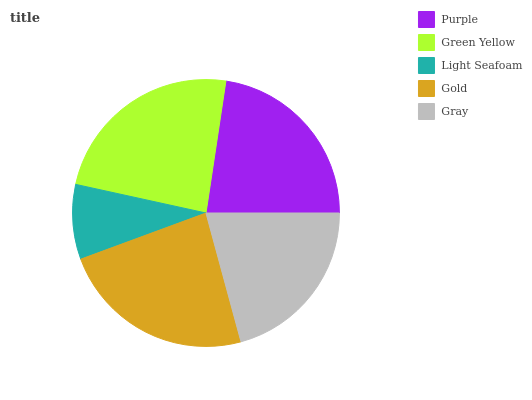Is Light Seafoam the minimum?
Answer yes or no. Yes. Is Green Yellow the maximum?
Answer yes or no. Yes. Is Green Yellow the minimum?
Answer yes or no. No. Is Light Seafoam the maximum?
Answer yes or no. No. Is Green Yellow greater than Light Seafoam?
Answer yes or no. Yes. Is Light Seafoam less than Green Yellow?
Answer yes or no. Yes. Is Light Seafoam greater than Green Yellow?
Answer yes or no. No. Is Green Yellow less than Light Seafoam?
Answer yes or no. No. Is Purple the high median?
Answer yes or no. Yes. Is Purple the low median?
Answer yes or no. Yes. Is Light Seafoam the high median?
Answer yes or no. No. Is Light Seafoam the low median?
Answer yes or no. No. 